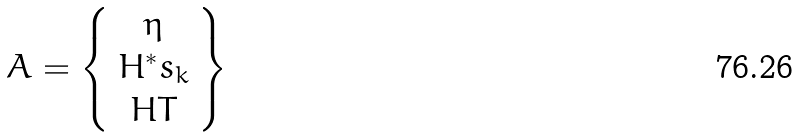<formula> <loc_0><loc_0><loc_500><loc_500>A = \left \{ \begin{array} { c } \eta \\ H ^ { * } s _ { k } \\ H T \end{array} \right \}</formula> 